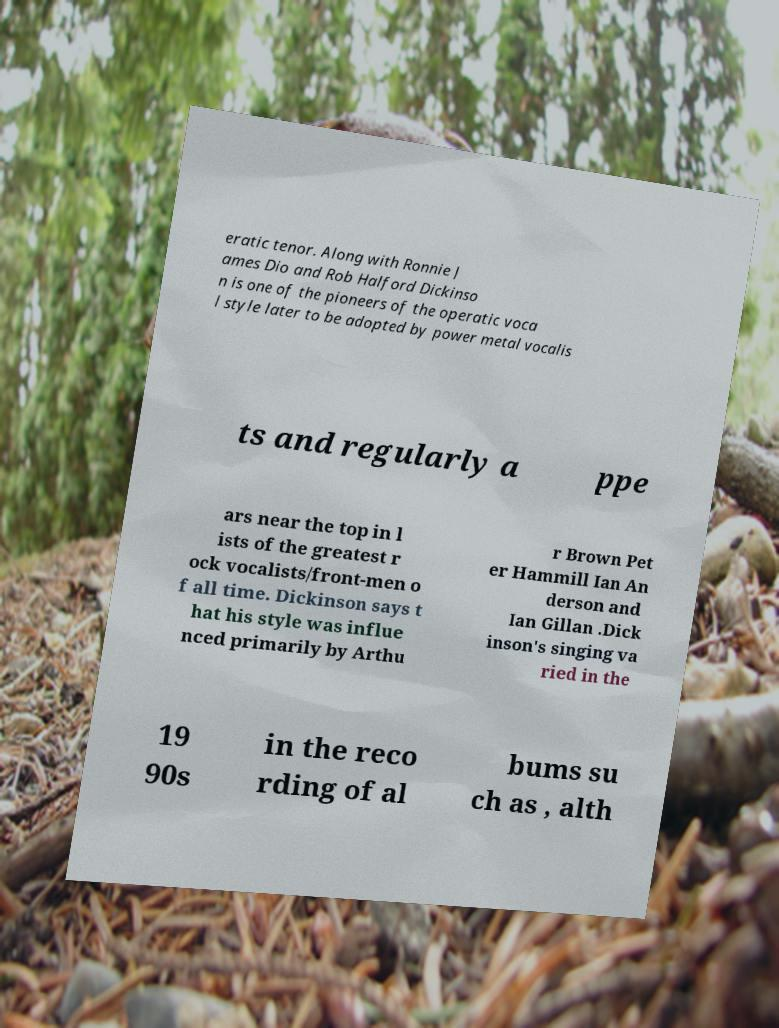What messages or text are displayed in this image? I need them in a readable, typed format. eratic tenor. Along with Ronnie J ames Dio and Rob Halford Dickinso n is one of the pioneers of the operatic voca l style later to be adopted by power metal vocalis ts and regularly a ppe ars near the top in l ists of the greatest r ock vocalists/front-men o f all time. Dickinson says t hat his style was influe nced primarily by Arthu r Brown Pet er Hammill Ian An derson and Ian Gillan .Dick inson's singing va ried in the 19 90s in the reco rding of al bums su ch as , alth 